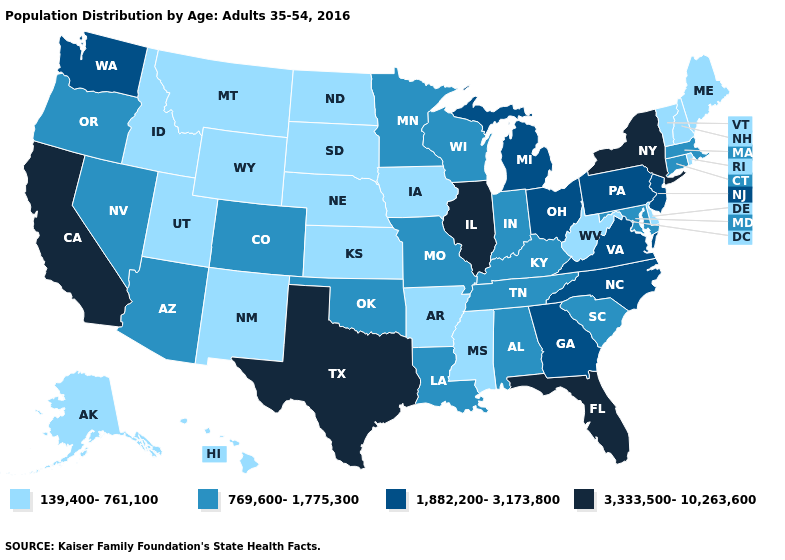Does Tennessee have a higher value than North Carolina?
Write a very short answer. No. Does Vermont have the lowest value in the Northeast?
Quick response, please. Yes. Is the legend a continuous bar?
Keep it brief. No. What is the value of Missouri?
Short answer required. 769,600-1,775,300. What is the value of Wyoming?
Short answer required. 139,400-761,100. What is the value of Wisconsin?
Write a very short answer. 769,600-1,775,300. Does Illinois have the same value as New Hampshire?
Concise answer only. No. Does Tennessee have a lower value than Arkansas?
Keep it brief. No. Name the states that have a value in the range 139,400-761,100?
Quick response, please. Alaska, Arkansas, Delaware, Hawaii, Idaho, Iowa, Kansas, Maine, Mississippi, Montana, Nebraska, New Hampshire, New Mexico, North Dakota, Rhode Island, South Dakota, Utah, Vermont, West Virginia, Wyoming. Which states have the highest value in the USA?
Quick response, please. California, Florida, Illinois, New York, Texas. Name the states that have a value in the range 139,400-761,100?
Keep it brief. Alaska, Arkansas, Delaware, Hawaii, Idaho, Iowa, Kansas, Maine, Mississippi, Montana, Nebraska, New Hampshire, New Mexico, North Dakota, Rhode Island, South Dakota, Utah, Vermont, West Virginia, Wyoming. What is the lowest value in states that border Tennessee?
Short answer required. 139,400-761,100. How many symbols are there in the legend?
Concise answer only. 4. Does Illinois have the highest value in the USA?
Answer briefly. Yes. Name the states that have a value in the range 139,400-761,100?
Answer briefly. Alaska, Arkansas, Delaware, Hawaii, Idaho, Iowa, Kansas, Maine, Mississippi, Montana, Nebraska, New Hampshire, New Mexico, North Dakota, Rhode Island, South Dakota, Utah, Vermont, West Virginia, Wyoming. 